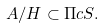Convert formula to latex. <formula><loc_0><loc_0><loc_500><loc_500>A / H \subset \Pi c S .</formula> 